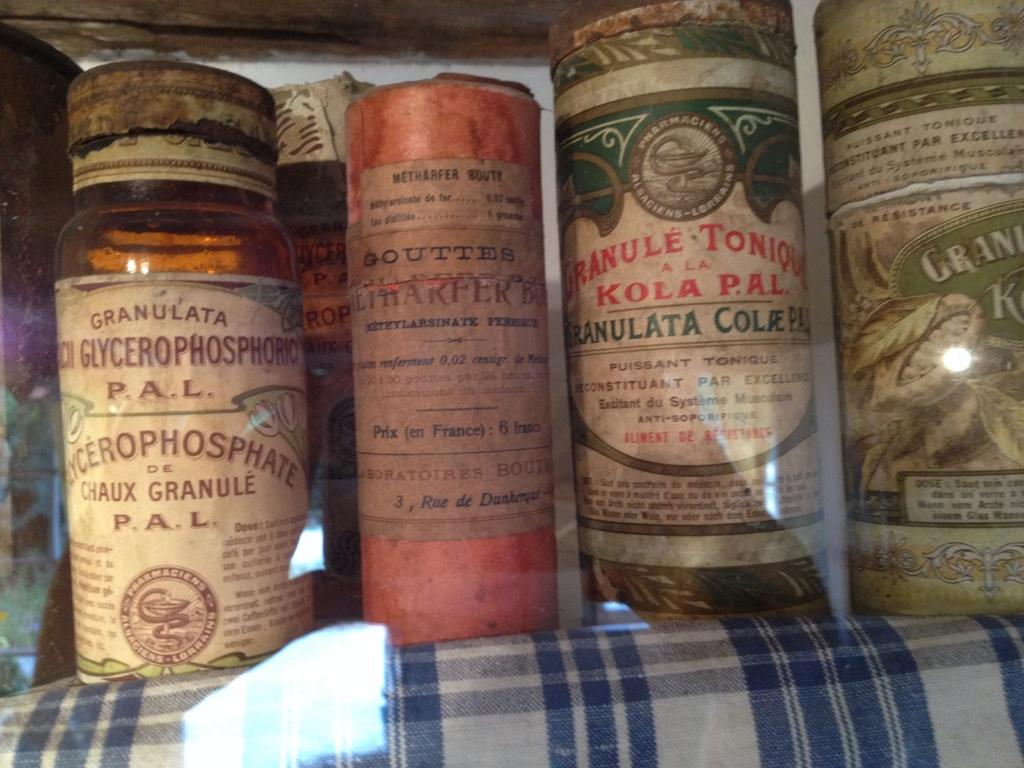Provide a one-sentence caption for the provided image. candles standing next to one another with one of htme labeled 'kola pal'. 